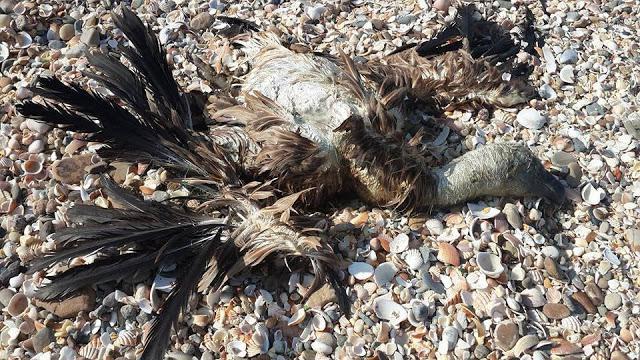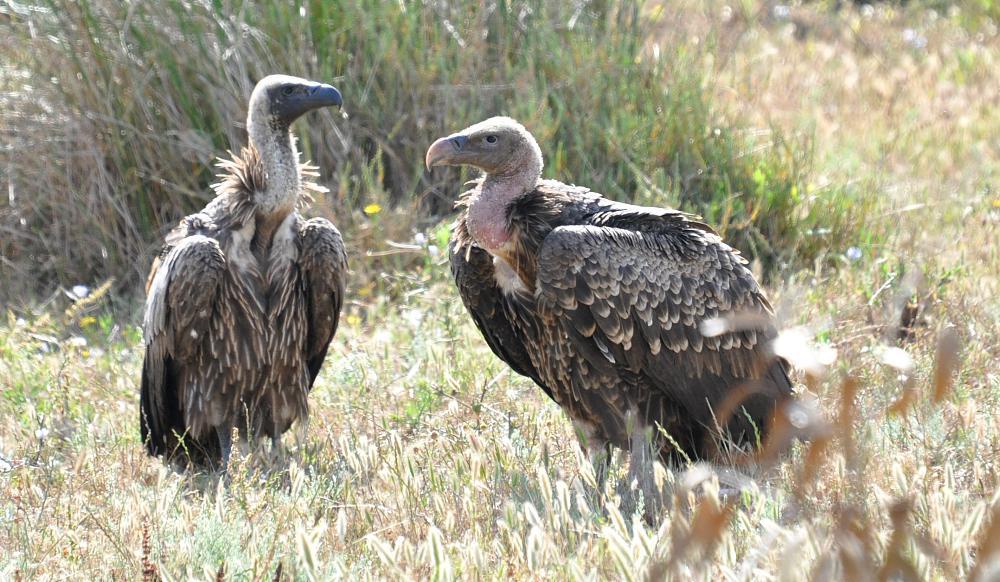The first image is the image on the left, the second image is the image on the right. Assess this claim about the two images: "There are more than four birds in the image to the right.". Correct or not? Answer yes or no. No. The first image is the image on the left, the second image is the image on the right. Analyze the images presented: Is the assertion "a vulture has a tag on its left wing" valid? Answer yes or no. No. 